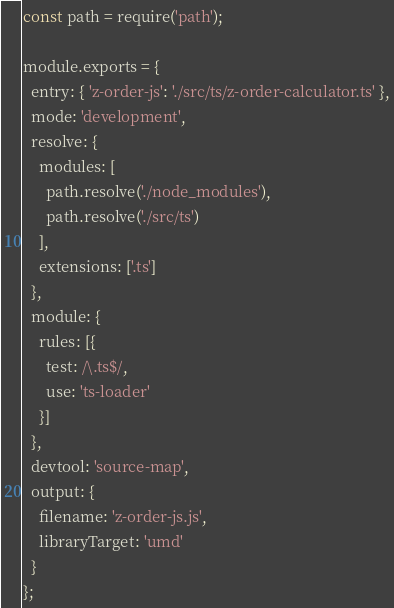<code> <loc_0><loc_0><loc_500><loc_500><_JavaScript_>const path = require('path');

module.exports = {
  entry: { 'z-order-js': './src/ts/z-order-calculator.ts' },
  mode: 'development',
  resolve: {
    modules: [
      path.resolve('./node_modules'),
      path.resolve('./src/ts')
    ],
    extensions: ['.ts']
  },
  module: {
    rules: [{
      test: /\.ts$/,
      use: 'ts-loader'
    }]
  },
  devtool: 'source-map',
  output: {
    filename: 'z-order-js.js',
    libraryTarget: 'umd'
  }
};

</code> 